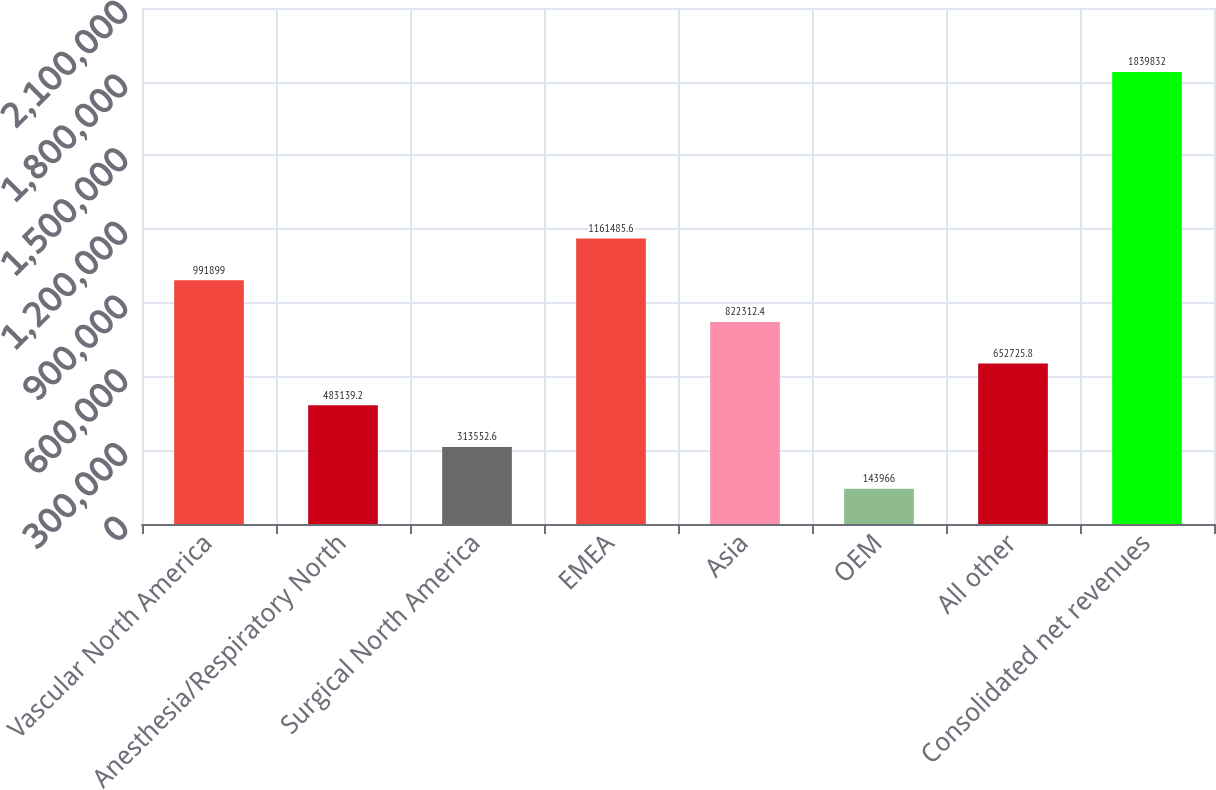Convert chart to OTSL. <chart><loc_0><loc_0><loc_500><loc_500><bar_chart><fcel>Vascular North America<fcel>Anesthesia/Respiratory North<fcel>Surgical North America<fcel>EMEA<fcel>Asia<fcel>OEM<fcel>All other<fcel>Consolidated net revenues<nl><fcel>991899<fcel>483139<fcel>313553<fcel>1.16149e+06<fcel>822312<fcel>143966<fcel>652726<fcel>1.83983e+06<nl></chart> 